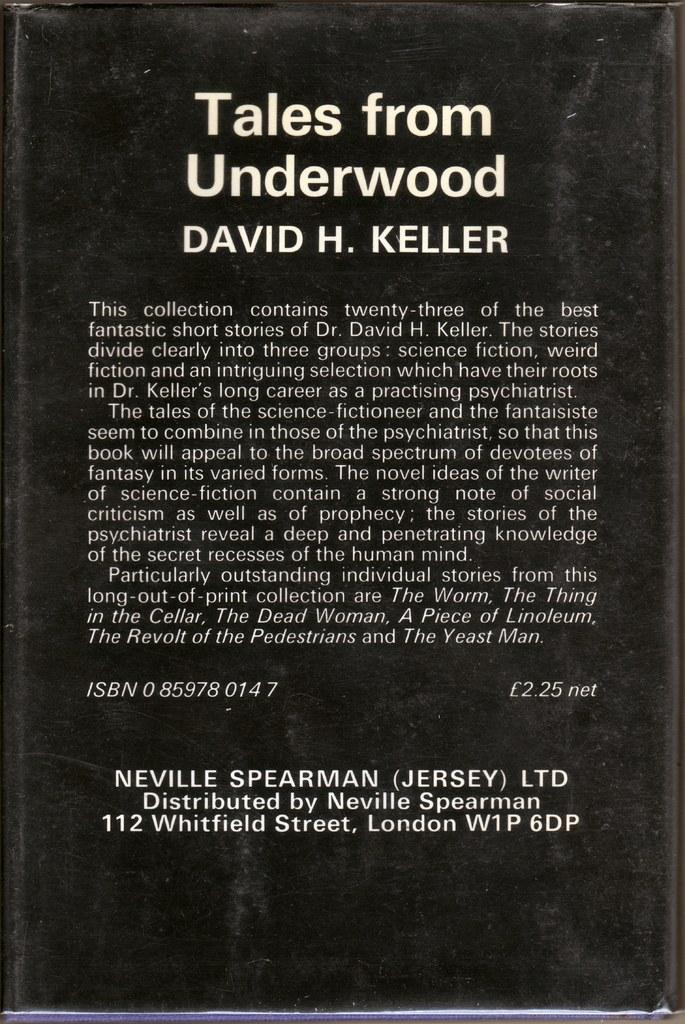<image>
Render a clear and concise summary of the photo. A closed hardback book with the title tails from underwood written on it. 